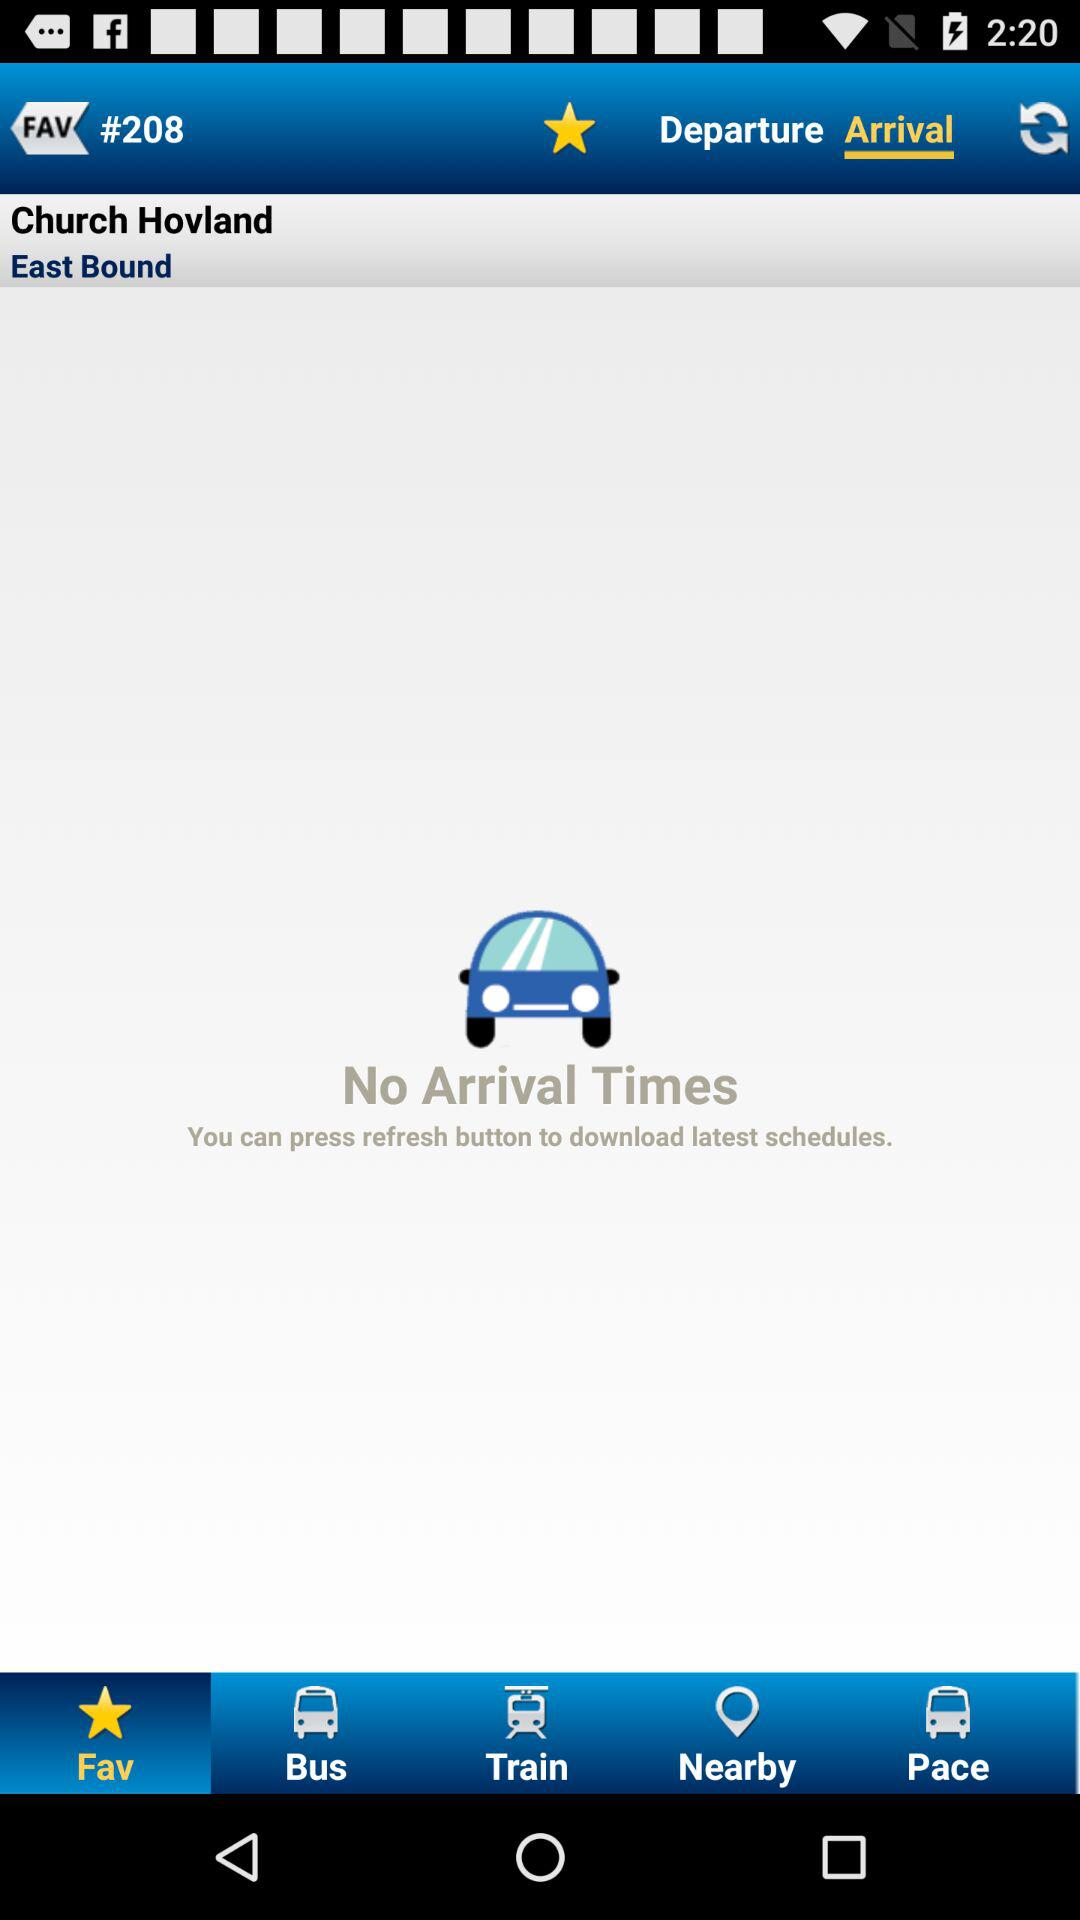Are there any given arrival times? There are no given arrival times. 